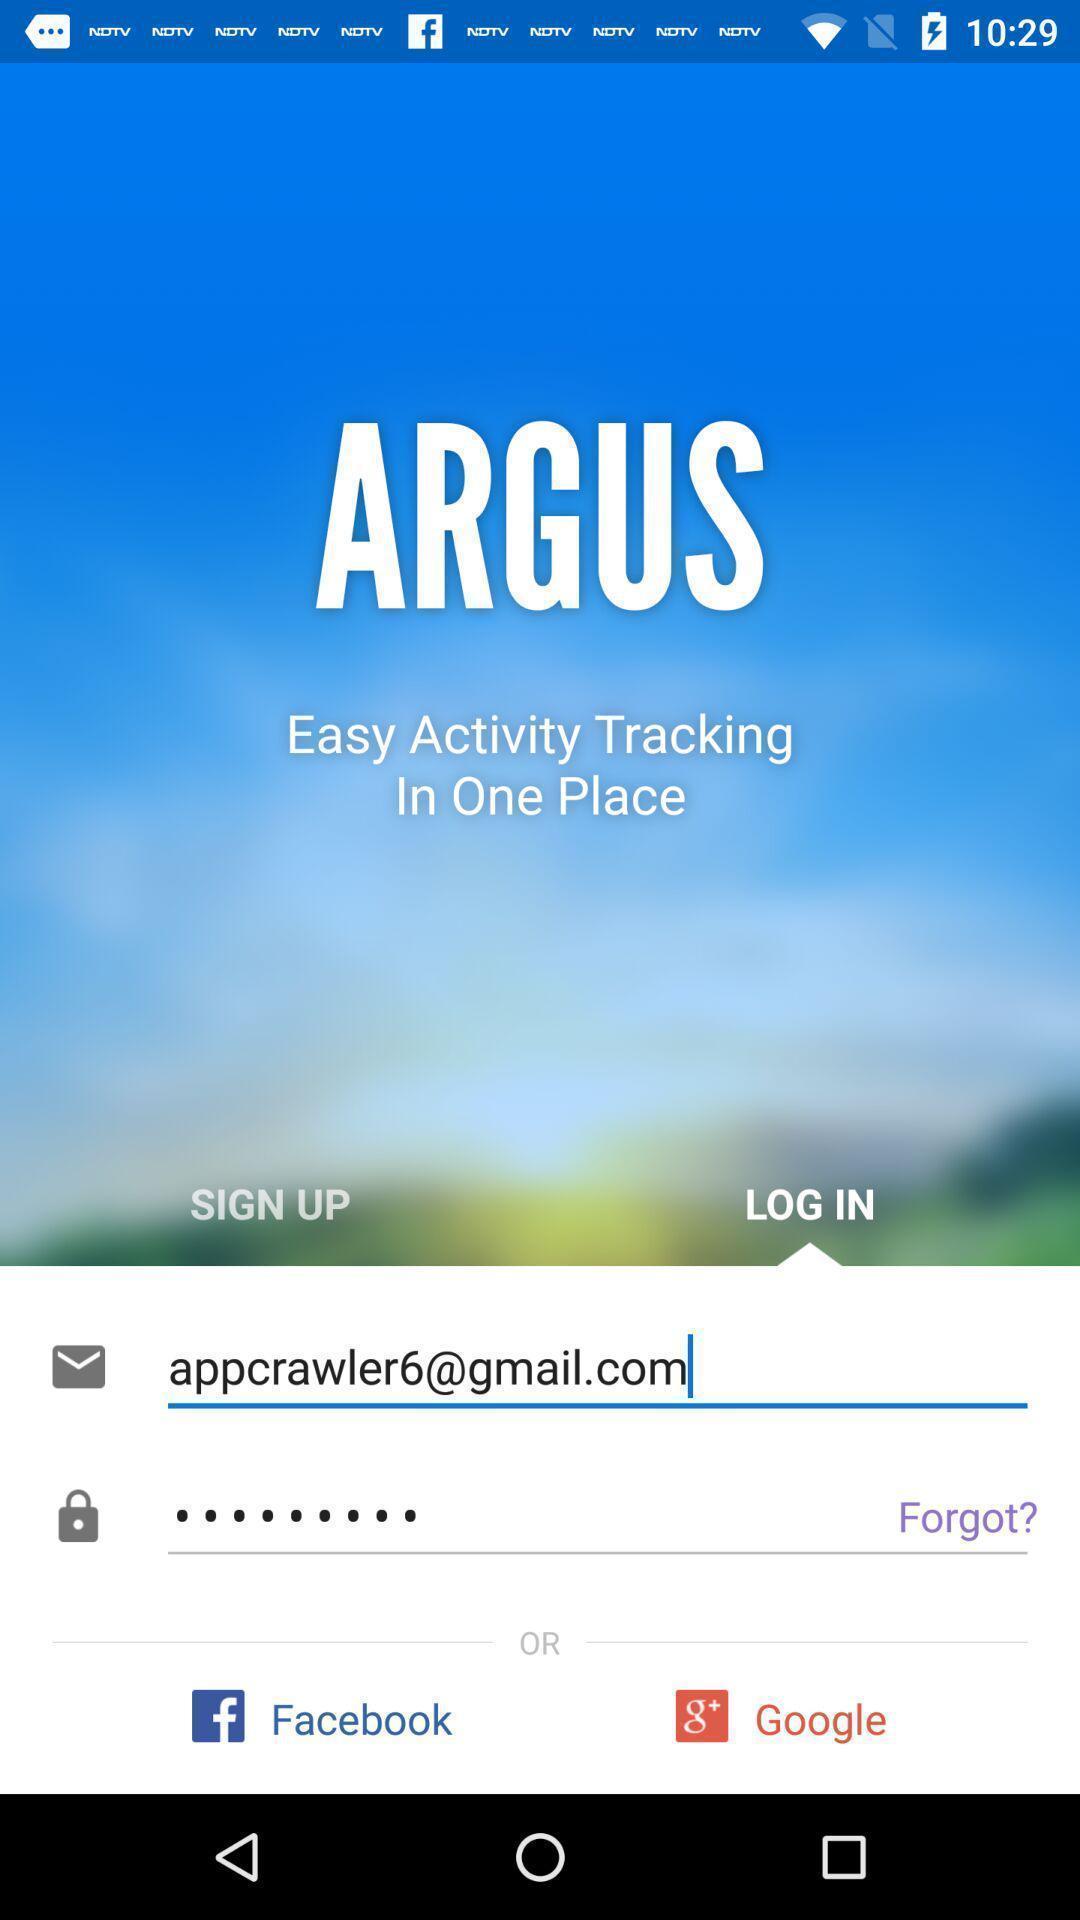Explain what's happening in this screen capture. Sign up/ log in page of health fitness application. 